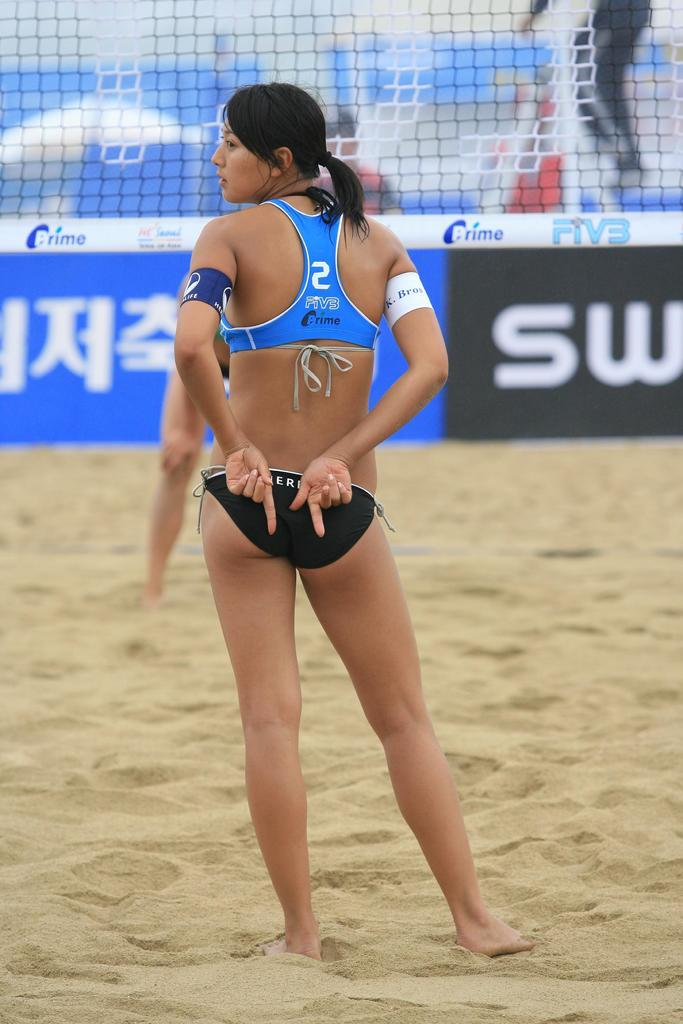Provide a one-sentence caption for the provided image. beach volleyball with player #2 giving a hand signal behind her back. 